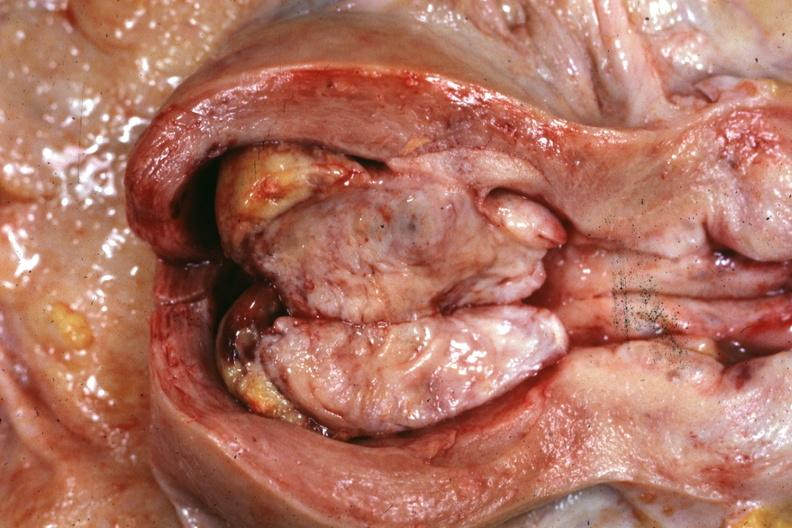s female reproductive present?
Answer the question using a single word or phrase. Yes 